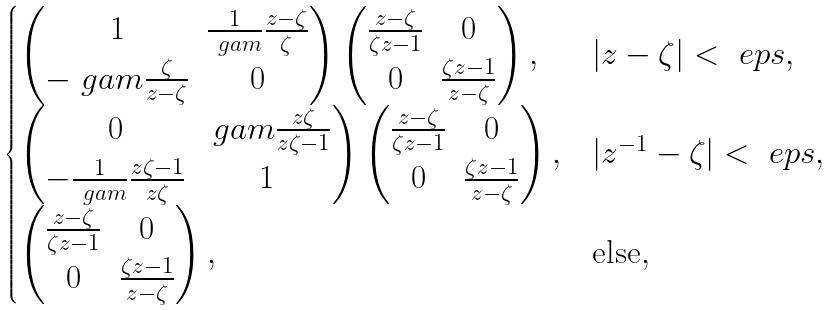Convert formula to latex. <formula><loc_0><loc_0><loc_500><loc_500>\begin{cases} \begin{pmatrix} 1 & \frac { 1 } { \ g a m } \frac { z - \zeta } { \zeta } \\ - \ g a m \frac { \zeta } { z - \zeta } & 0 \end{pmatrix} \begin{pmatrix} \frac { z - \zeta } { \zeta z - 1 } & 0 \\ 0 & \frac { \zeta z - 1 } { z - \zeta } \end{pmatrix} , & | z - \zeta | < \ e p s , \\ \begin{pmatrix} 0 & \ g a m \frac { z \zeta } { z \zeta - 1 } \\ - \frac { 1 } { \ g a m } \frac { z \zeta - 1 } { z \zeta } & 1 \end{pmatrix} \begin{pmatrix} \frac { z - \zeta } { \zeta z - 1 } & 0 \\ 0 & \frac { \zeta z - 1 } { z - \zeta } \end{pmatrix} , & | z ^ { - 1 } - \zeta | < \ e p s , \\ \begin{pmatrix} \frac { z - \zeta } { \zeta z - 1 } & 0 \\ 0 & \frac { \zeta z - 1 } { z - \zeta } \end{pmatrix} , & \text {else} , \end{cases}</formula> 